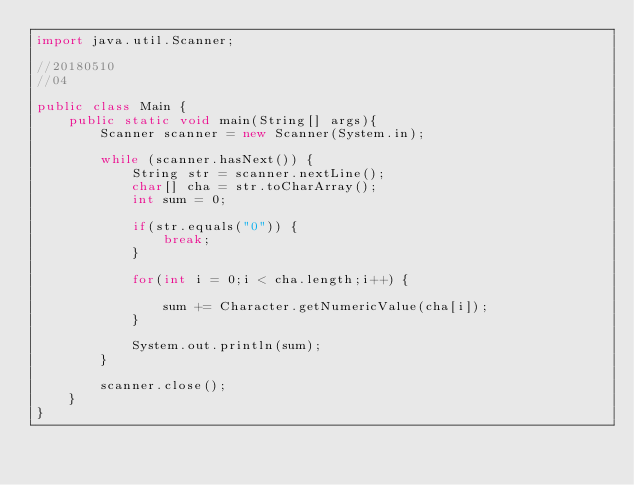<code> <loc_0><loc_0><loc_500><loc_500><_Java_>import java.util.Scanner;

//20180510
//04

public class Main {
    public static void main(String[] args){
		Scanner scanner = new Scanner(System.in);

		while (scanner.hasNext()) {
			String str = scanner.nextLine();
			char[] cha = str.toCharArray();
			int sum = 0;

			if(str.equals("0")) {
				break;
			}

			for(int i = 0;i < cha.length;i++) {

				sum += Character.getNumericValue(cha[i]);
			}

			System.out.println(sum);
		}

		scanner.close();
    }
}
</code> 